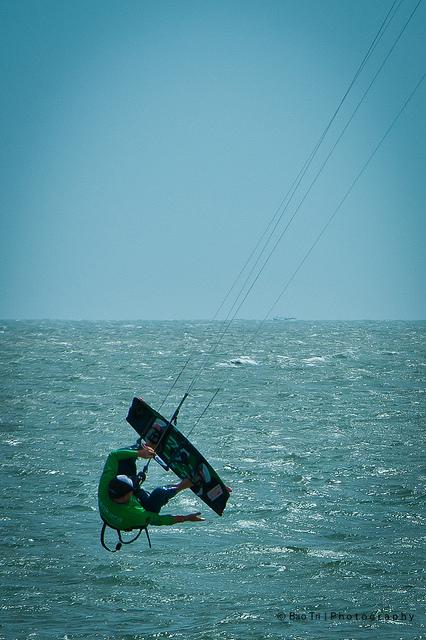What sport is this?
Be succinct. Parasailing. Is this a water activity?
Be succinct. Yes. What keeps the man from going underwater?
Give a very brief answer. Board. 